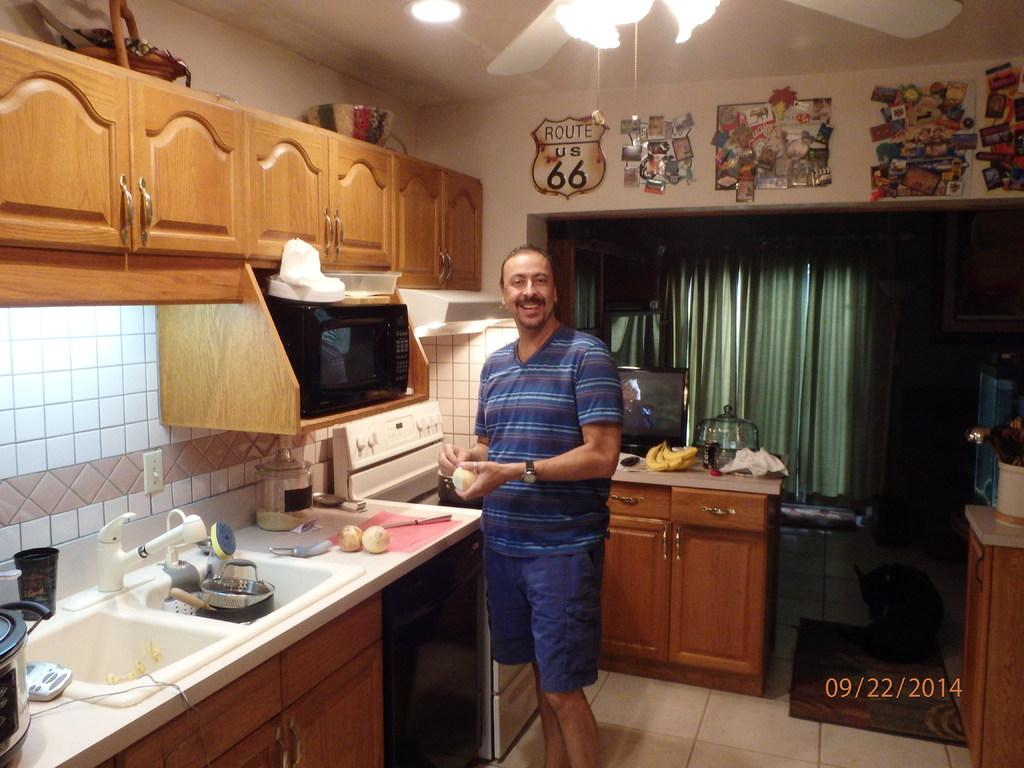<image>
Give a short and clear explanation of the subsequent image. A man cooking in his kitchen on September 22, 2014. 